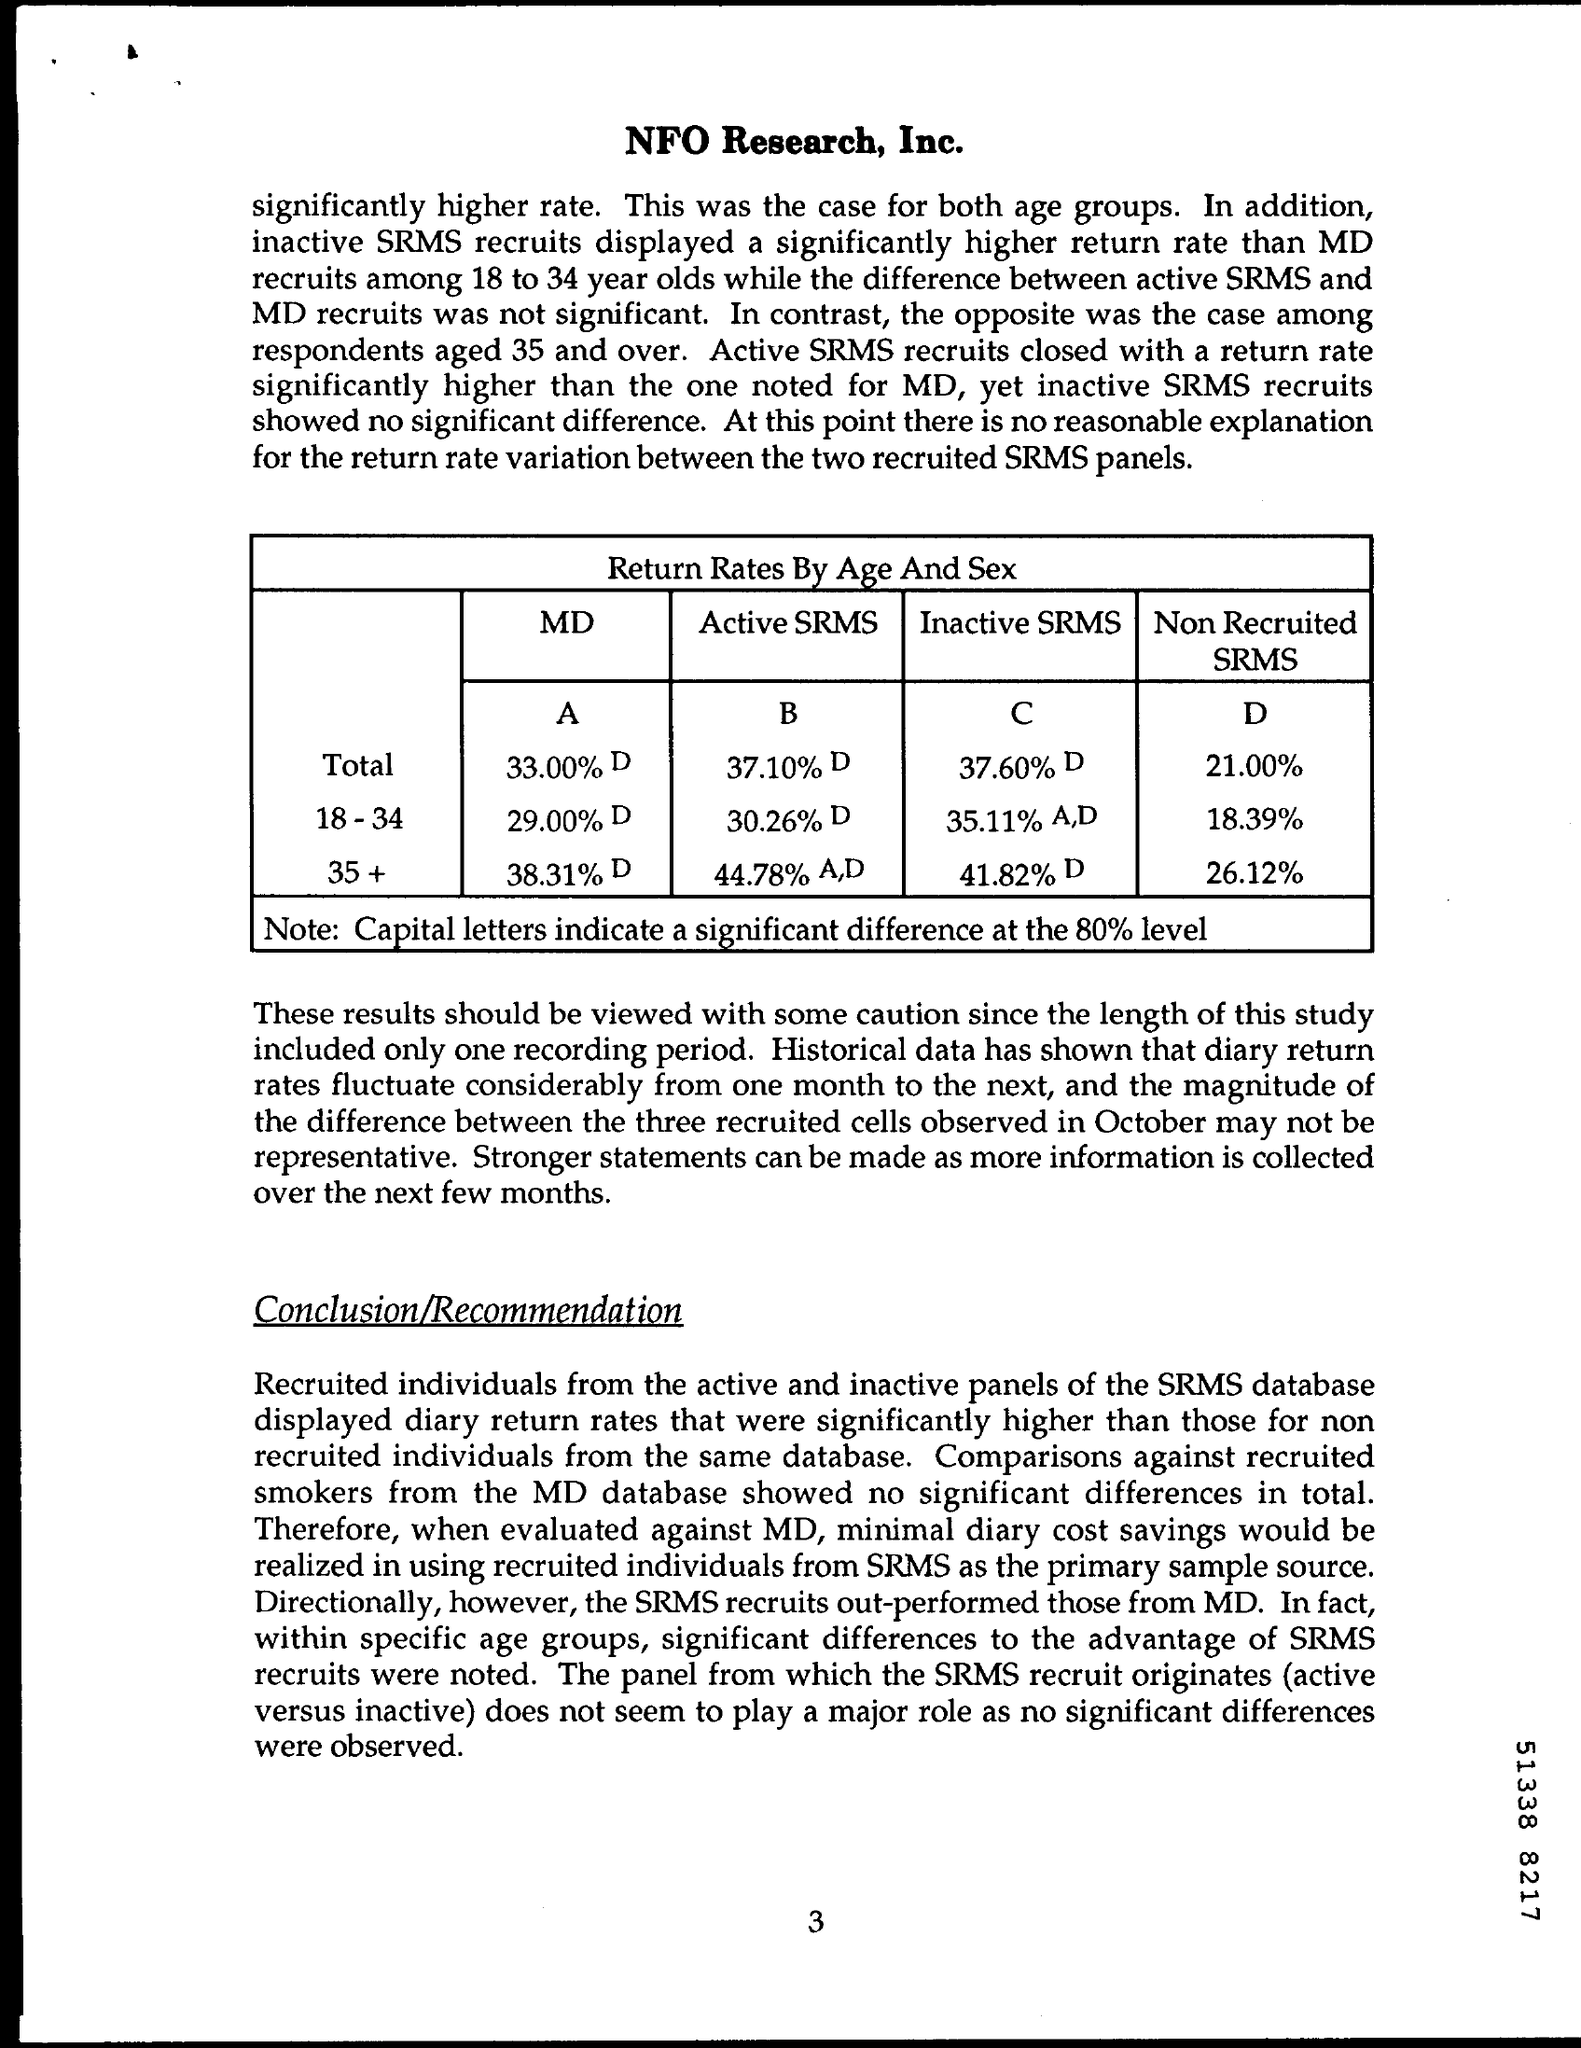What is the page number on this document?
 3 